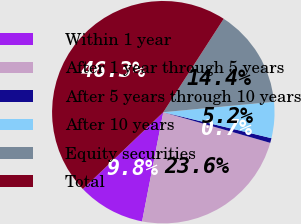<chart> <loc_0><loc_0><loc_500><loc_500><pie_chart><fcel>Within 1 year<fcel>After 1 year through 5 years<fcel>After 5 years through 10 years<fcel>After 10 years<fcel>Equity securities<fcel>Total<nl><fcel>9.81%<fcel>23.61%<fcel>0.69%<fcel>5.25%<fcel>14.37%<fcel>46.27%<nl></chart> 